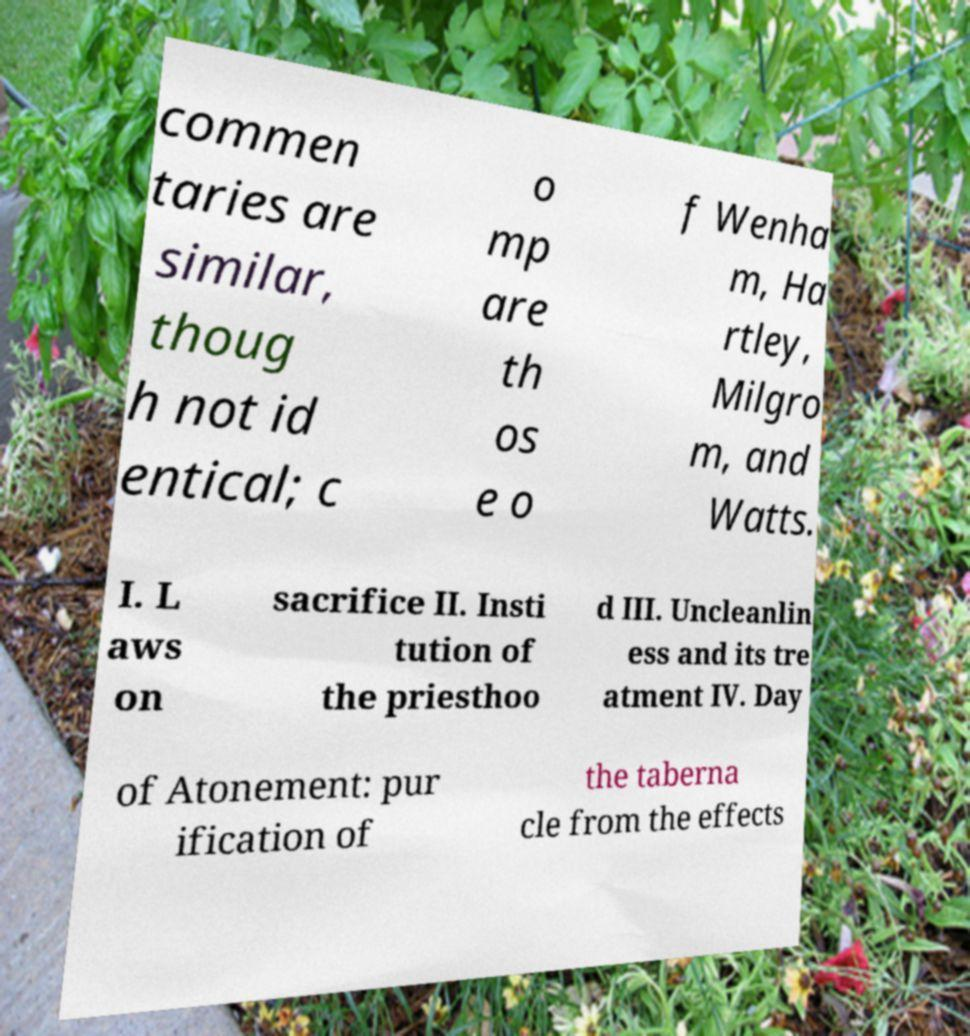What messages or text are displayed in this image? I need them in a readable, typed format. commen taries are similar, thoug h not id entical; c o mp are th os e o f Wenha m, Ha rtley, Milgro m, and Watts. I. L aws on sacrifice II. Insti tution of the priesthoo d III. Uncleanlin ess and its tre atment IV. Day of Atonement: pur ification of the taberna cle from the effects 